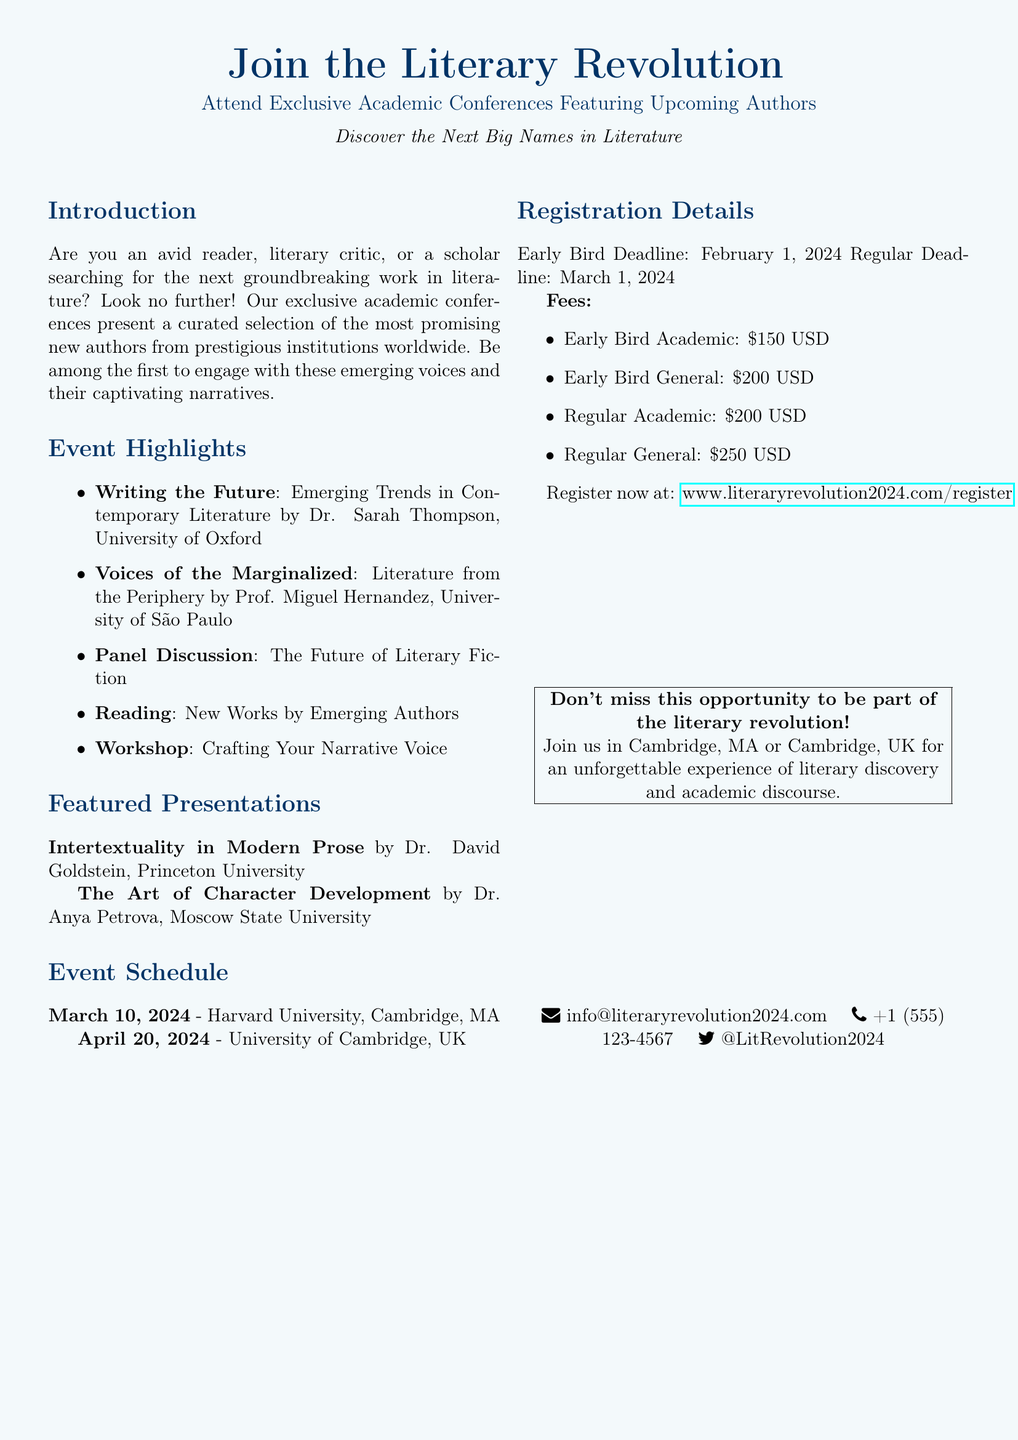What is the title of the event? The title of the event is prominently displayed at the top of the document, showcasing the main theme.
Answer: Join the Literary Revolution Who is speaking about "Emerging Trends in Contemporary Literature"? This information can be found under the Event Highlights section, listing the presenters with their topics.
Answer: Dr. Sarah Thompson What is the date of the first event location? The date is specified in the Event Schedule section, indicating when the first event will take place.
Answer: March 10, 2024 What is the early bird registration fee for general participants? The fees are listed in the Registration Details section, showing distinct pricing for different categories.
Answer: $200 USD Which university is hosting the second event? The second event's location is also mentioned in the Event Schedule section, showing the host university.
Answer: University of Cambridge What is the early bird registration deadline? The deadline for early registration is specifically indicated in the Registration Details section of the document.
Answer: February 1, 2024 What type of event discusses "The Future of Literary Fiction"? This detail about the event type is found in the Event Highlights section, describing the nature of the planned discussion.
Answer: Panel Discussion How can one register for the event? The registration method is provided in the Registration Details section, detailing where to go for registration.
Answer: www.literaryrevolution2024.com/register 